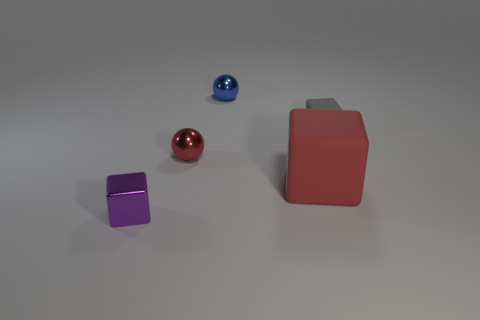What is the material of the ball that is the same color as the big matte block?
Provide a short and direct response. Metal. How many tiny metal objects are the same color as the large block?
Keep it short and to the point. 1. Are there fewer small purple metal blocks behind the purple shiny thing than tiny metallic balls that are behind the tiny rubber block?
Offer a very short reply. Yes. What is the blue sphere made of?
Your answer should be compact. Metal. Is the color of the large cube the same as the small metal thing behind the gray cube?
Offer a terse response. No. What number of blue metallic things are in front of the small red metallic object?
Offer a very short reply. 0. Is the number of red rubber things in front of the tiny purple metal cube less than the number of small blue metallic objects?
Offer a very short reply. Yes. The big rubber cube has what color?
Ensure brevity in your answer.  Red. Is the color of the metal sphere that is behind the small matte cube the same as the metallic cube?
Make the answer very short. No. What is the color of the tiny metal object that is the same shape as the big object?
Give a very brief answer. Purple. 